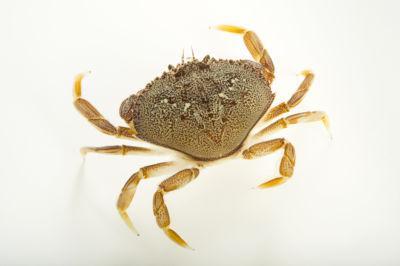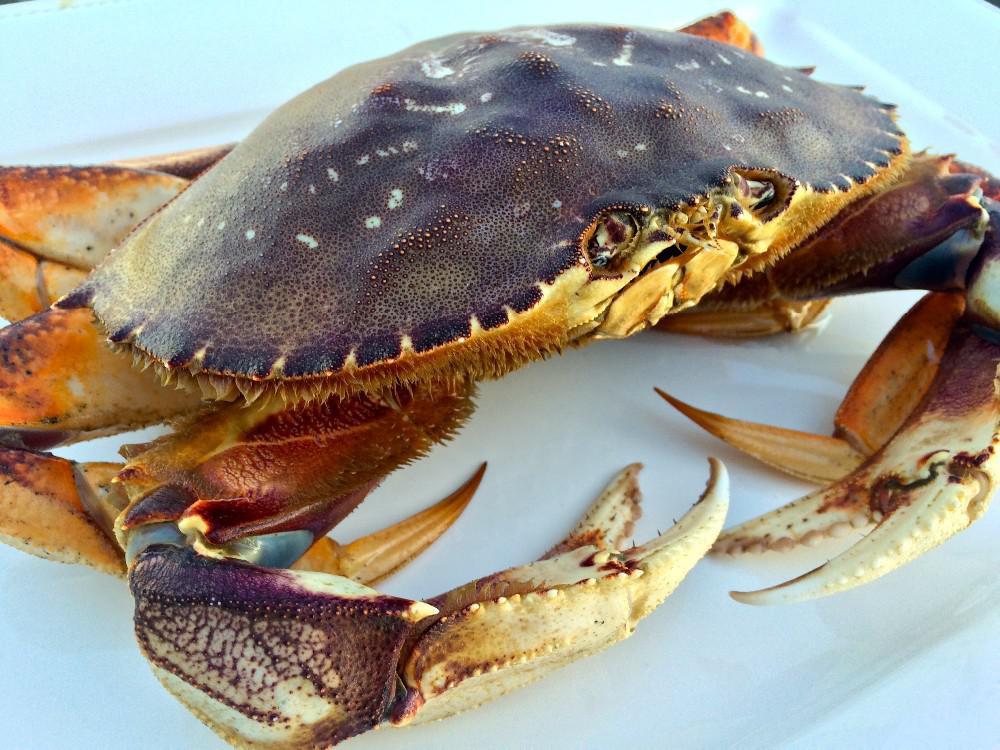The first image is the image on the left, the second image is the image on the right. Evaluate the accuracy of this statement regarding the images: "The left and right image contains the same number of crabs facing the same direction.". Is it true? Answer yes or no. No. The first image is the image on the left, the second image is the image on the right. Evaluate the accuracy of this statement regarding the images: "Both crabs are facing the same direction.". Is it true? Answer yes or no. No. 